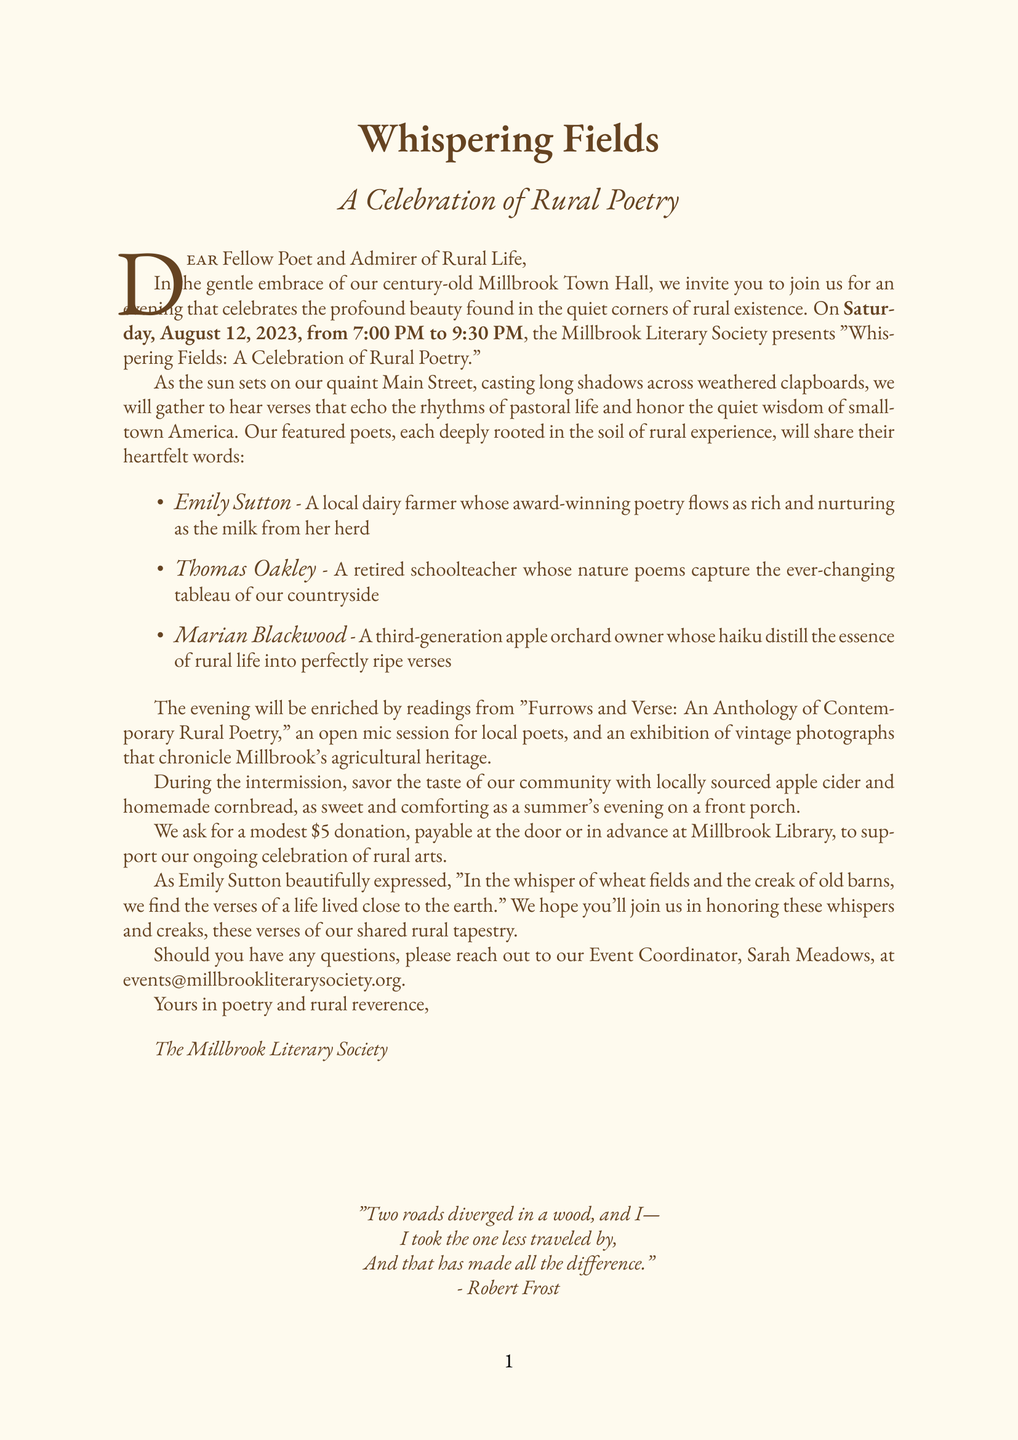What is the name of the event? The name of the event is stated in the document as "Whispering Fields: A Celebration of Rural Poetry."
Answer: Whispering Fields: A Celebration of Rural Poetry When is the event taking place? The date of the event is clearly mentioned and is essential information for attendees.
Answer: Saturday, August 12, 2023 What is the venue for the event? The document specifies Millbrook Town Hall as the venue.
Answer: Millbrook Town Hall Who is the event coordinator? The name of the contact person for inquiries is provided in the document.
Answer: Sarah Meadows What is the suggested donation for the event? The document states the amount requested for attendance, which supports the event.
Answer: $5 suggested donation What will attendees enjoy during the intermission? The document mentions specific refreshments that will be served during the intermission.
Answer: Locally sourced apple cider and homemade cornbread What type of session will be held for local poets? The event description indicates there will be a session for poets to participate actively.
Answer: Open mic session What notable work will be collectively read at the event's conclusion? The letter highlights a famous poem to be read collectively at the end.
Answer: Robert Frost's 'The Road Not Taken' What year was the Millbrook Town Hall built? The historical significance section provides the construction year of the town hall.
Answer: 1898 